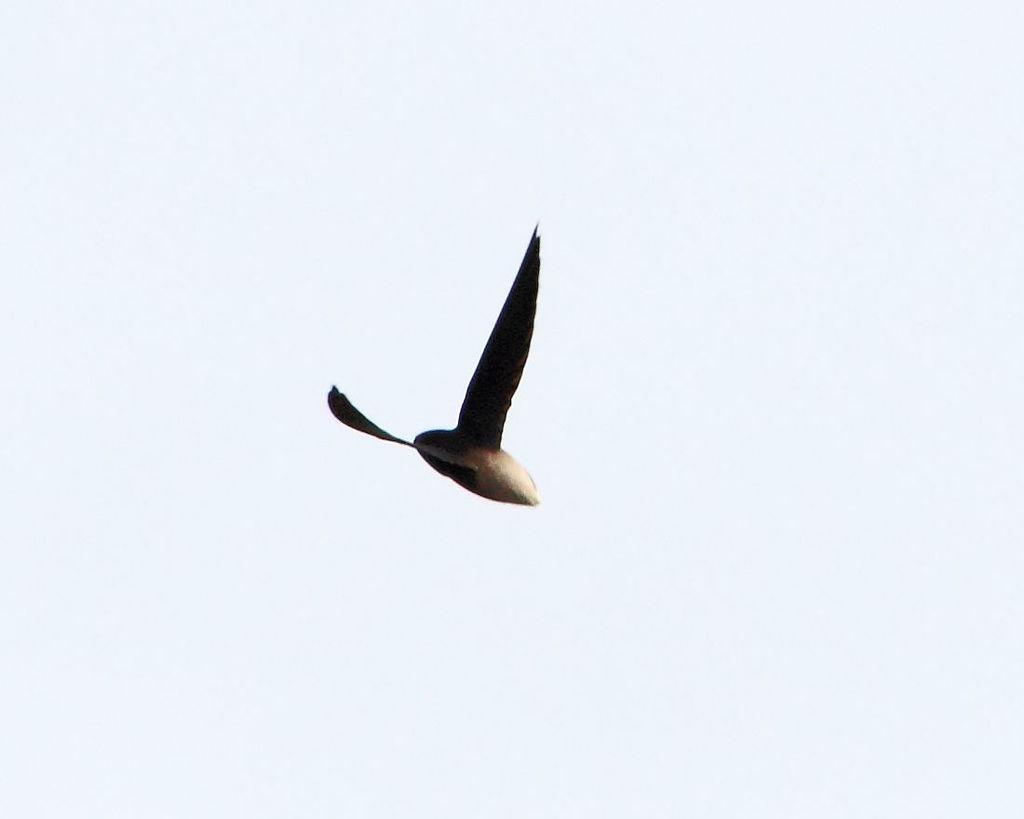Describe this image in one or two sentences. In the middle of this image there is a bird flying in the air. In the background, I can see the sky. 